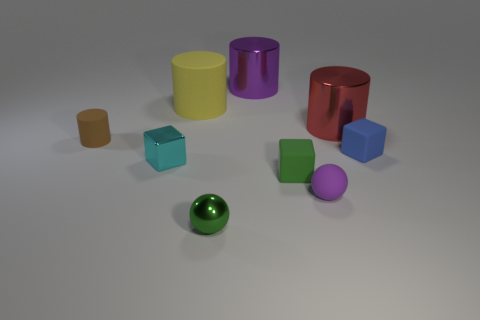There is a tiny matte object that is the same color as the tiny shiny ball; what shape is it? cube 